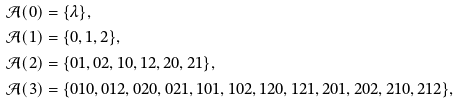<formula> <loc_0><loc_0><loc_500><loc_500>\mathcal { A } ( 0 ) & = \{ \lambda \} , \\ \mathcal { A } ( 1 ) & = \{ 0 , 1 , 2 \} , \\ \mathcal { A } ( 2 ) & = \{ 0 1 , 0 2 , 1 0 , 1 2 , 2 0 , 2 1 \} , \\ \mathcal { A } ( 3 ) & = \{ 0 1 0 , 0 1 2 , 0 2 0 , 0 2 1 , 1 0 1 , 1 0 2 , 1 2 0 , 1 2 1 , 2 0 1 , 2 0 2 , 2 1 0 , 2 1 2 \} ,</formula> 